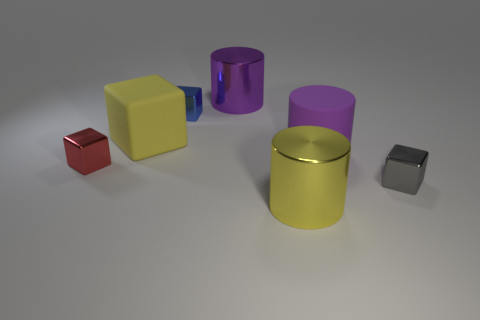How many big yellow objects are both behind the big yellow shiny object and to the right of the rubber block?
Your response must be concise. 0. There is a purple object in front of the blue metallic block; does it have the same size as the large matte cube?
Offer a very short reply. Yes. What size is the thing that is the same material as the big yellow cube?
Give a very brief answer. Large. Are there more tiny red metallic things that are in front of the big rubber cylinder than yellow rubber cubes that are behind the large yellow rubber thing?
Your answer should be compact. Yes. Does the tiny gray block right of the blue thing have the same material as the yellow cylinder?
Provide a short and direct response. Yes. What is the color of the other big metal thing that is the same shape as the large purple metal object?
Ensure brevity in your answer.  Yellow. What is the shape of the yellow object that is in front of the tiny red shiny cube?
Your answer should be very brief. Cylinder. Is there anything else that is the same size as the gray thing?
Your answer should be compact. Yes. What is the color of the other large cylinder that is the same material as the big yellow cylinder?
Offer a terse response. Purple. Do the large cylinder that is in front of the small red metal thing and the tiny metal object that is behind the purple rubber object have the same color?
Provide a succinct answer. No. 